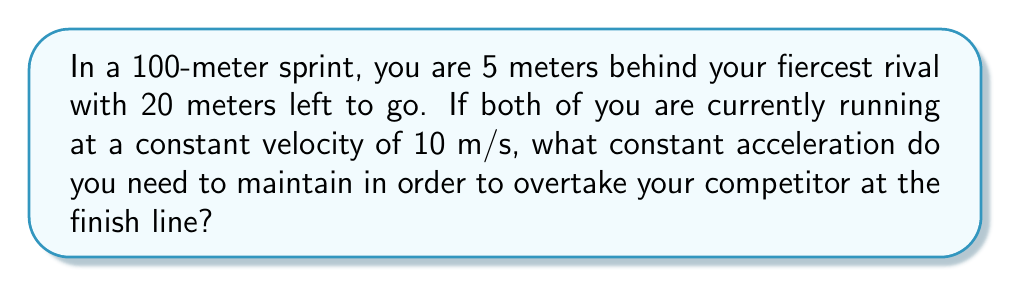Provide a solution to this math problem. Let's approach this step-by-step:

1) First, we need to set up our equations of motion. We'll use:
   $$s = ut + \frac{1}{2}at^2$$
   where $s$ is displacement, $u$ is initial velocity, $a$ is acceleration, and $t$ is time.

2) For your rival:
   $$s_r = 20 \text{ m}$$
   $$u_r = 10 \text{ m/s}$$
   $$a_r = 0 \text{ m/s}^2$$ (constant velocity)
   $$20 = 10t + \frac{1}{2}(0)t^2$$
   $$t = 2 \text{ s}$$ (time to finish for your rival)

3) For you:
   $$s_y = 25 \text{ m}$$ (20 m + 5 m you're behind)
   $$u_y = 10 \text{ m/s}$$
   $$25 = 10t + \frac{1}{2}at^2$$

4) We want to finish at the same time as your rival, so $t = 2 \text{ s}$. Substituting this:
   $$25 = 10(2) + \frac{1}{2}a(2)^2$$
   $$25 = 20 + 2a$$
   $$5 = 2a$$
   $$a = 2.5 \text{ m/s}^2$$

Therefore, you need to maintain a constant acceleration of 2.5 m/s² to overtake your rival at the finish line.
Answer: $2.5 \text{ m/s}^2$ 